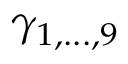Convert formula to latex. <formula><loc_0><loc_0><loc_500><loc_500>\gamma _ { 1 , \dots , 9 }</formula> 